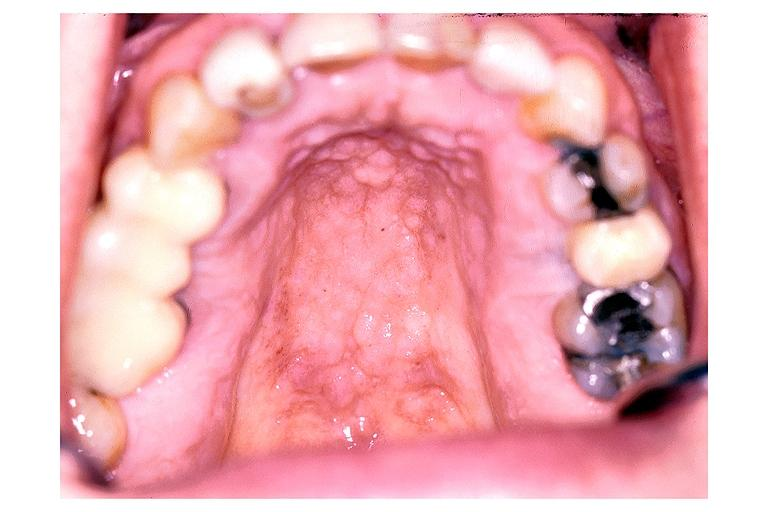s one present?
Answer the question using a single word or phrase. No 